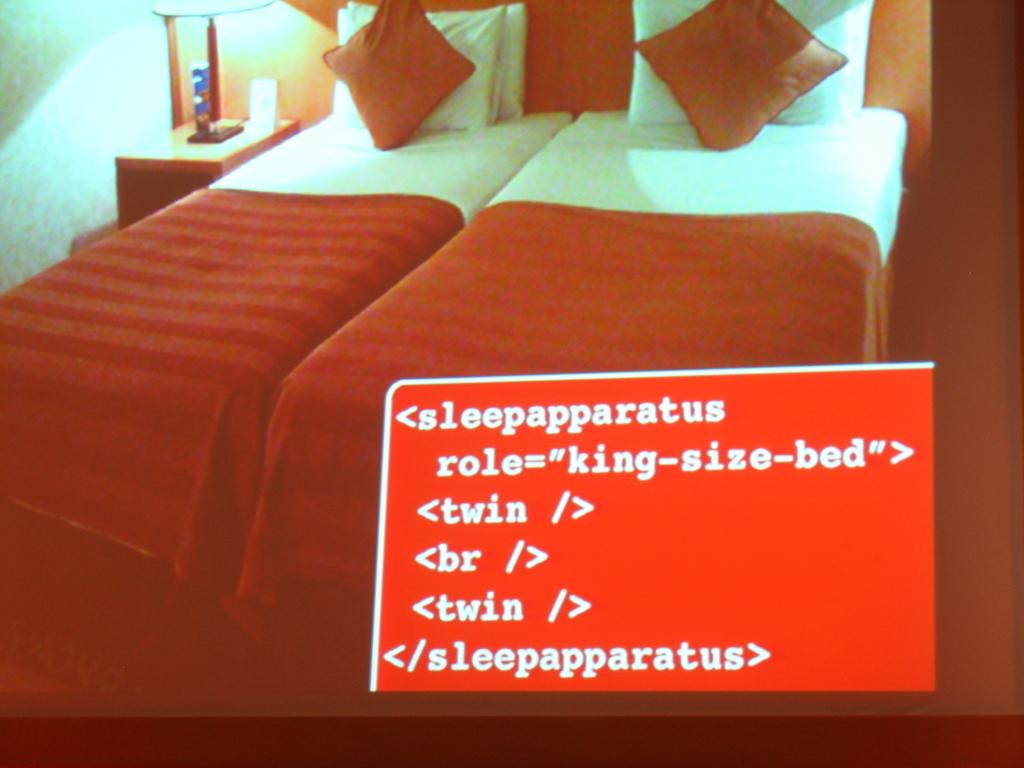What type of furniture is present in the image? There are beds with bed-sheets and pillows in the image. What is located beside the bed? There is a table beside the bed. What is on the table? There is a lamp on the table, as well as other things. What can be seen on the wall? There is something written on the picture on the wall. What is the purpose of the wall? This is a wall, which serves as a structural element and can also be used for displaying items like the picture. How many calculators are visible on the table in the image? There are no calculators visible on the table in the image. What type of flock is flying outside the window in the image? There is no window or flock visible in the image. 